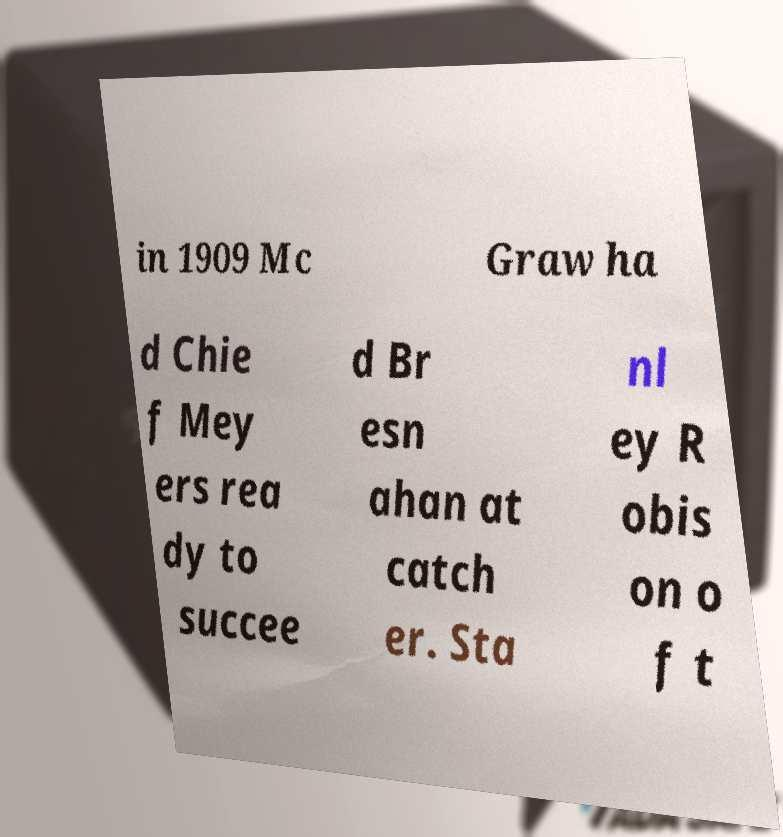Please identify and transcribe the text found in this image. in 1909 Mc Graw ha d Chie f Mey ers rea dy to succee d Br esn ahan at catch er. Sta nl ey R obis on o f t 